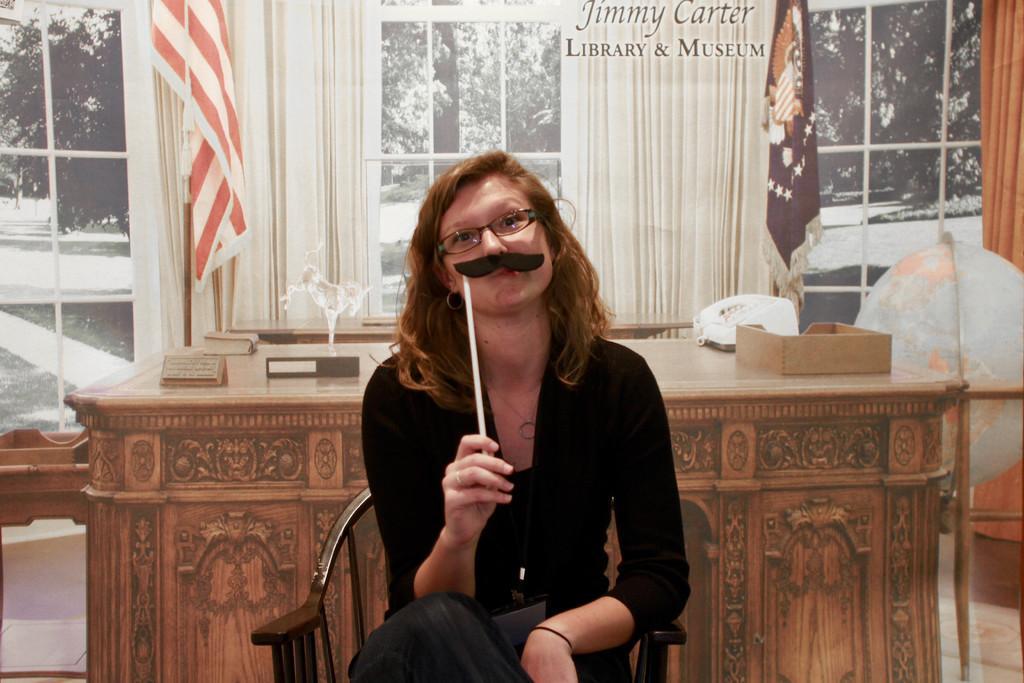Could you give a brief overview of what you see in this image? In this image there is a woman sitting on a chair is holding some object in her hand, behind the woman there is a table with some objects on the table, behind the table there are two flags, behind the flags there are curtains on the glass window, behind the curtains there are trees. 